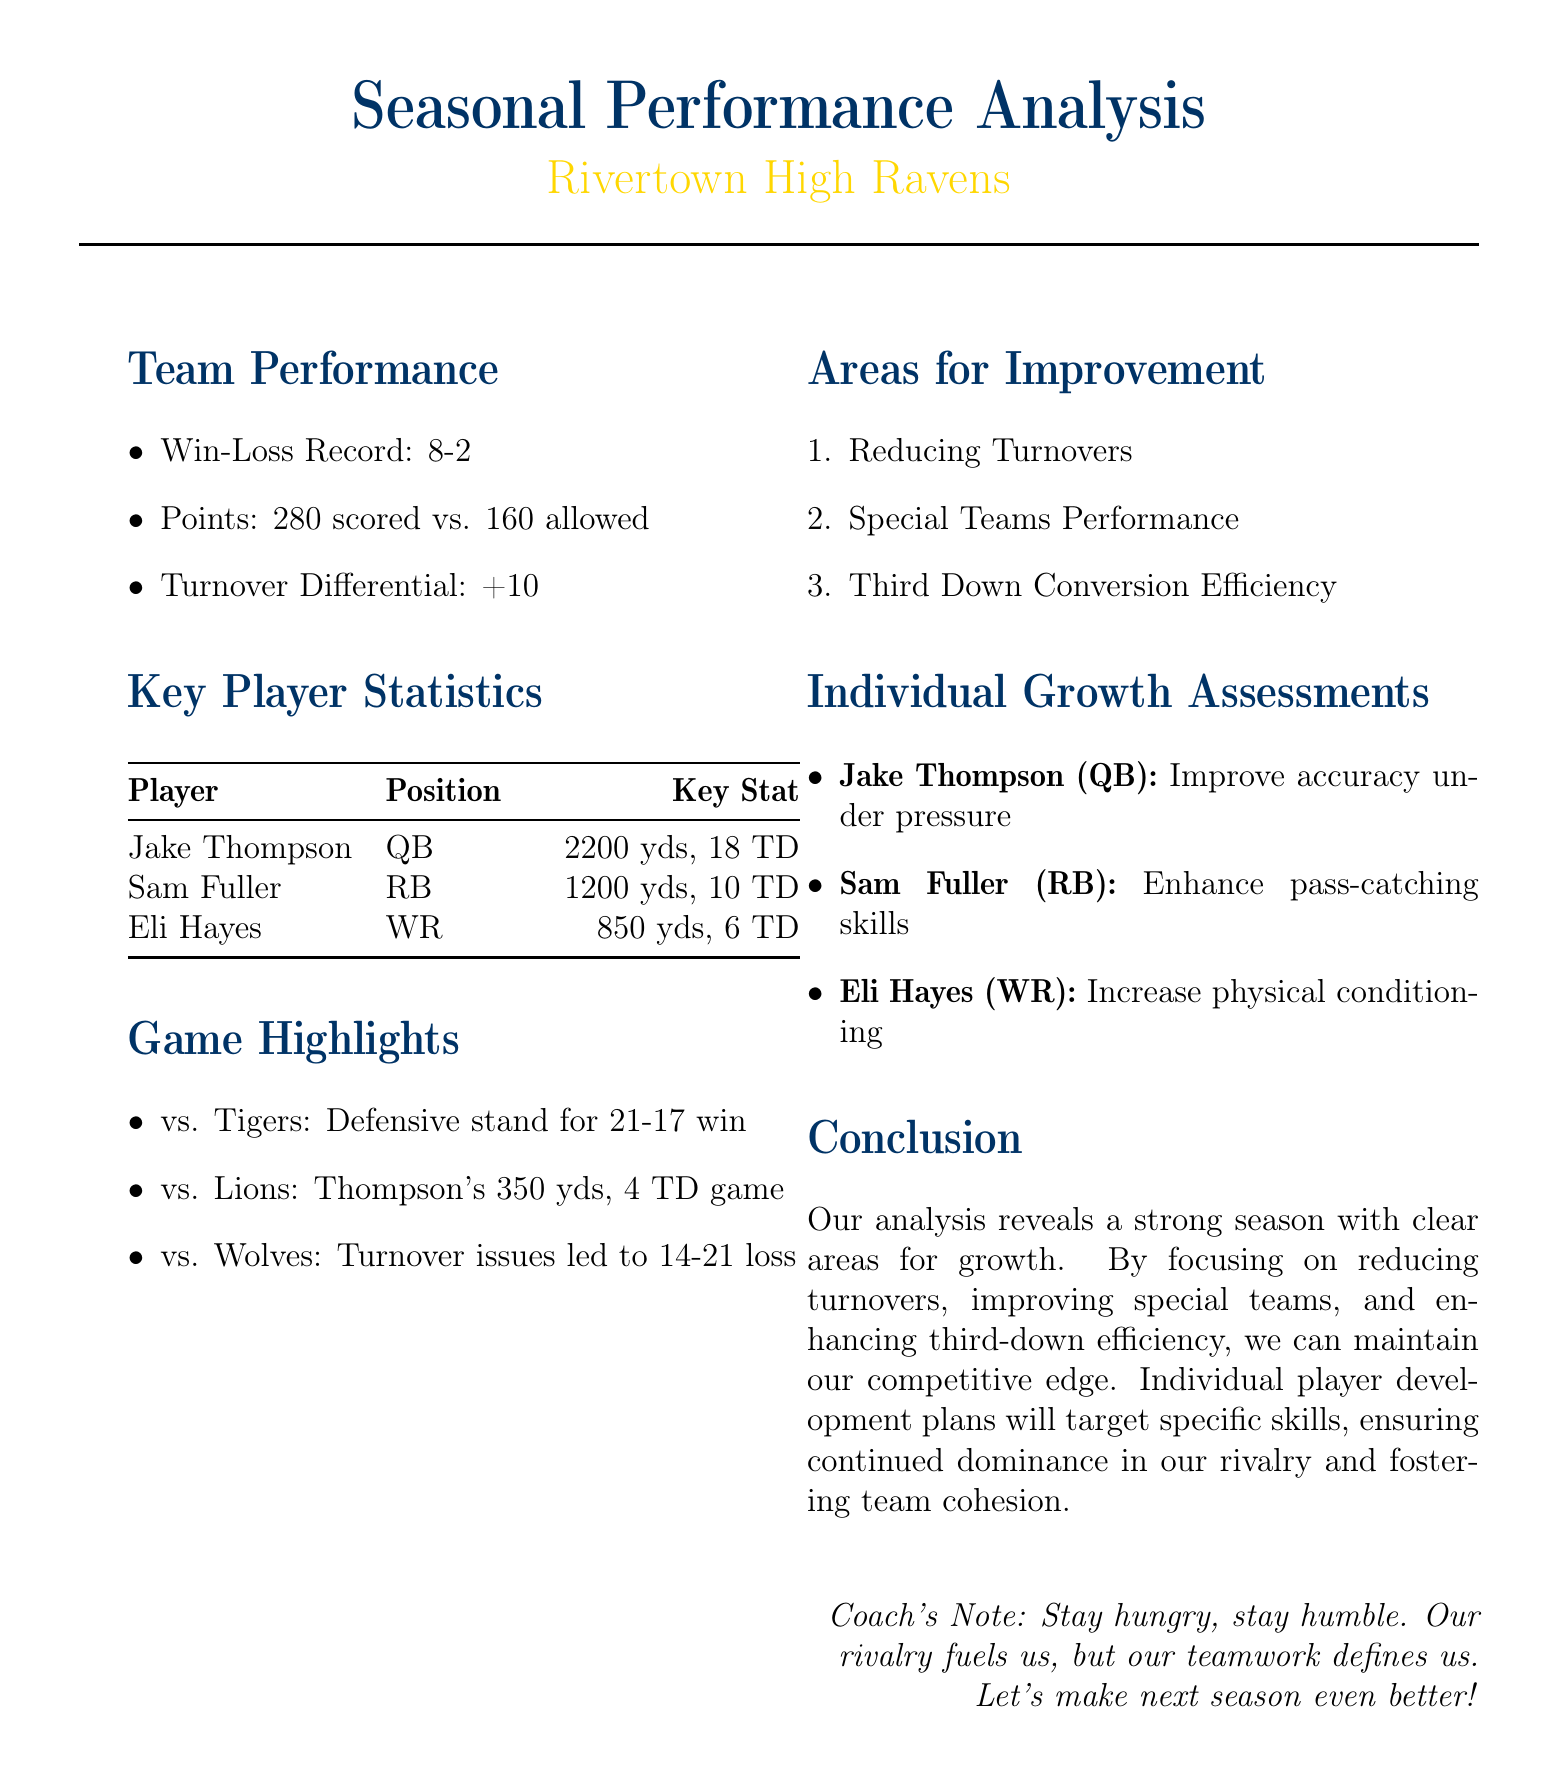What is the team's win-loss record? The document states the team's win-loss record clearly in the team performance section.
Answer: 8-2 How many points did the team score during the season? The total points scored by the team is mentioned in the performance analysis.
Answer: 280 Who is the key player with the highest passing yards? The analysis lists key player statistics, showing who had the highest yards among players.
Answer: Jake Thompson What is the turnover differential for the team? The turnover differential is specified in the team performance segment.
Answer: +10 Which area needs improvement related to Special Teams? One of the areas highlighted for improvement pertains specifically to special teams performance.
Answer: Special Teams Performance What skill should Sam Fuller enhance? Individual growth assessments focus on skills players need to develop, indicating what Fuller needs to work on.
Answer: Pass-catching skills What notable game lead to a loss due to turnover issues? The document cites a specific game that referenced turnover problems resulting in a defeat.
Answer: vs. Wolves What is one of the team's strengths indicated by points allowed? The document includes aspects of team performance, identifying points allowed as a strength.
Answer: 160 